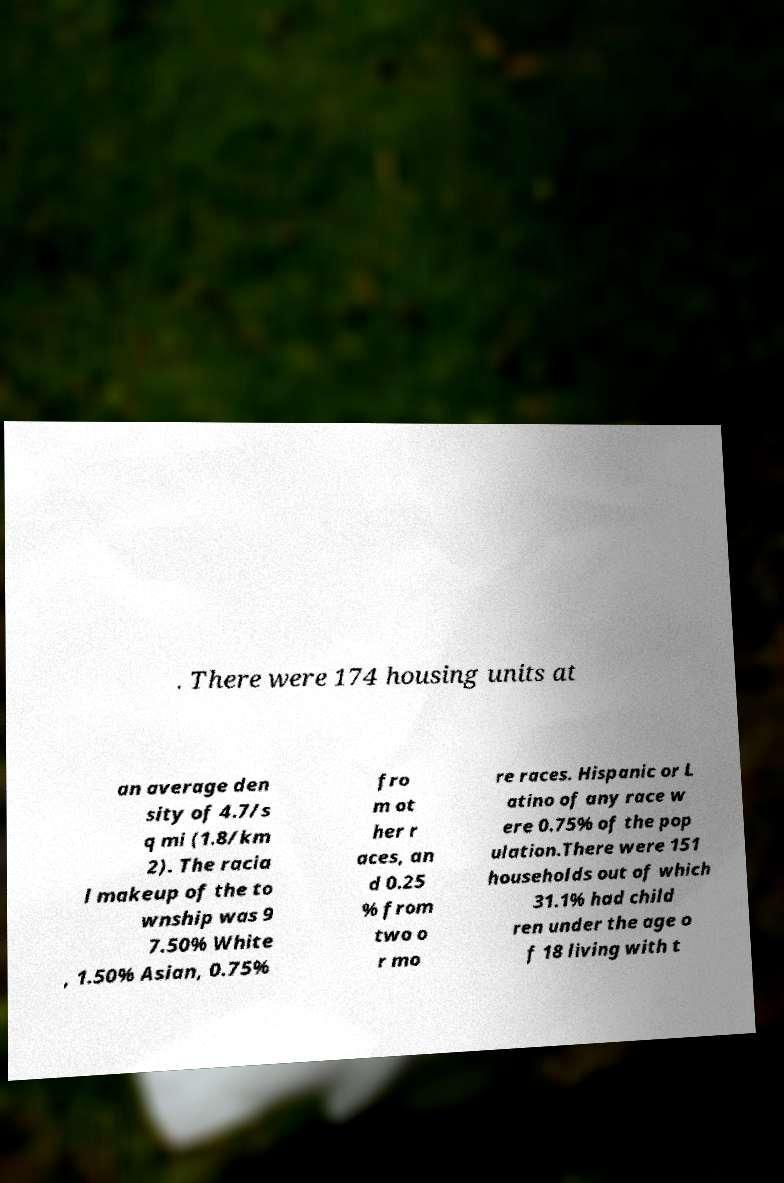Please read and relay the text visible in this image. What does it say? . There were 174 housing units at an average den sity of 4.7/s q mi (1.8/km 2). The racia l makeup of the to wnship was 9 7.50% White , 1.50% Asian, 0.75% fro m ot her r aces, an d 0.25 % from two o r mo re races. Hispanic or L atino of any race w ere 0.75% of the pop ulation.There were 151 households out of which 31.1% had child ren under the age o f 18 living with t 